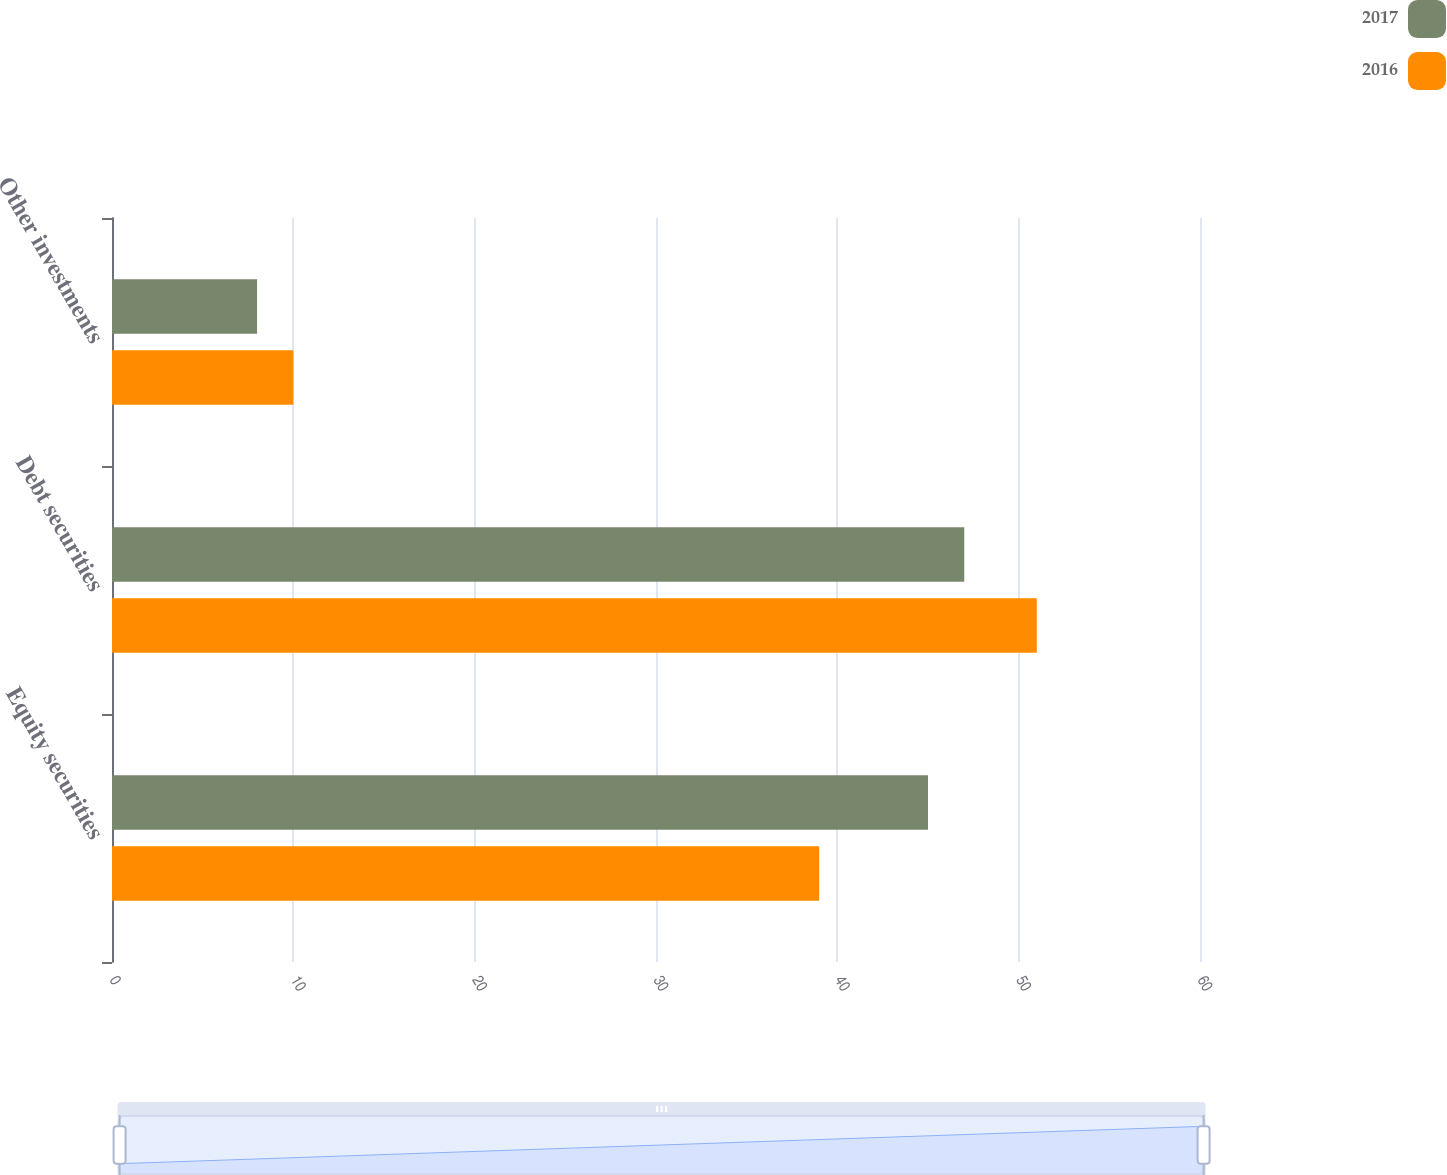<chart> <loc_0><loc_0><loc_500><loc_500><stacked_bar_chart><ecel><fcel>Equity securities<fcel>Debt securities<fcel>Other investments<nl><fcel>2017<fcel>45<fcel>47<fcel>8<nl><fcel>2016<fcel>39<fcel>51<fcel>10<nl></chart> 